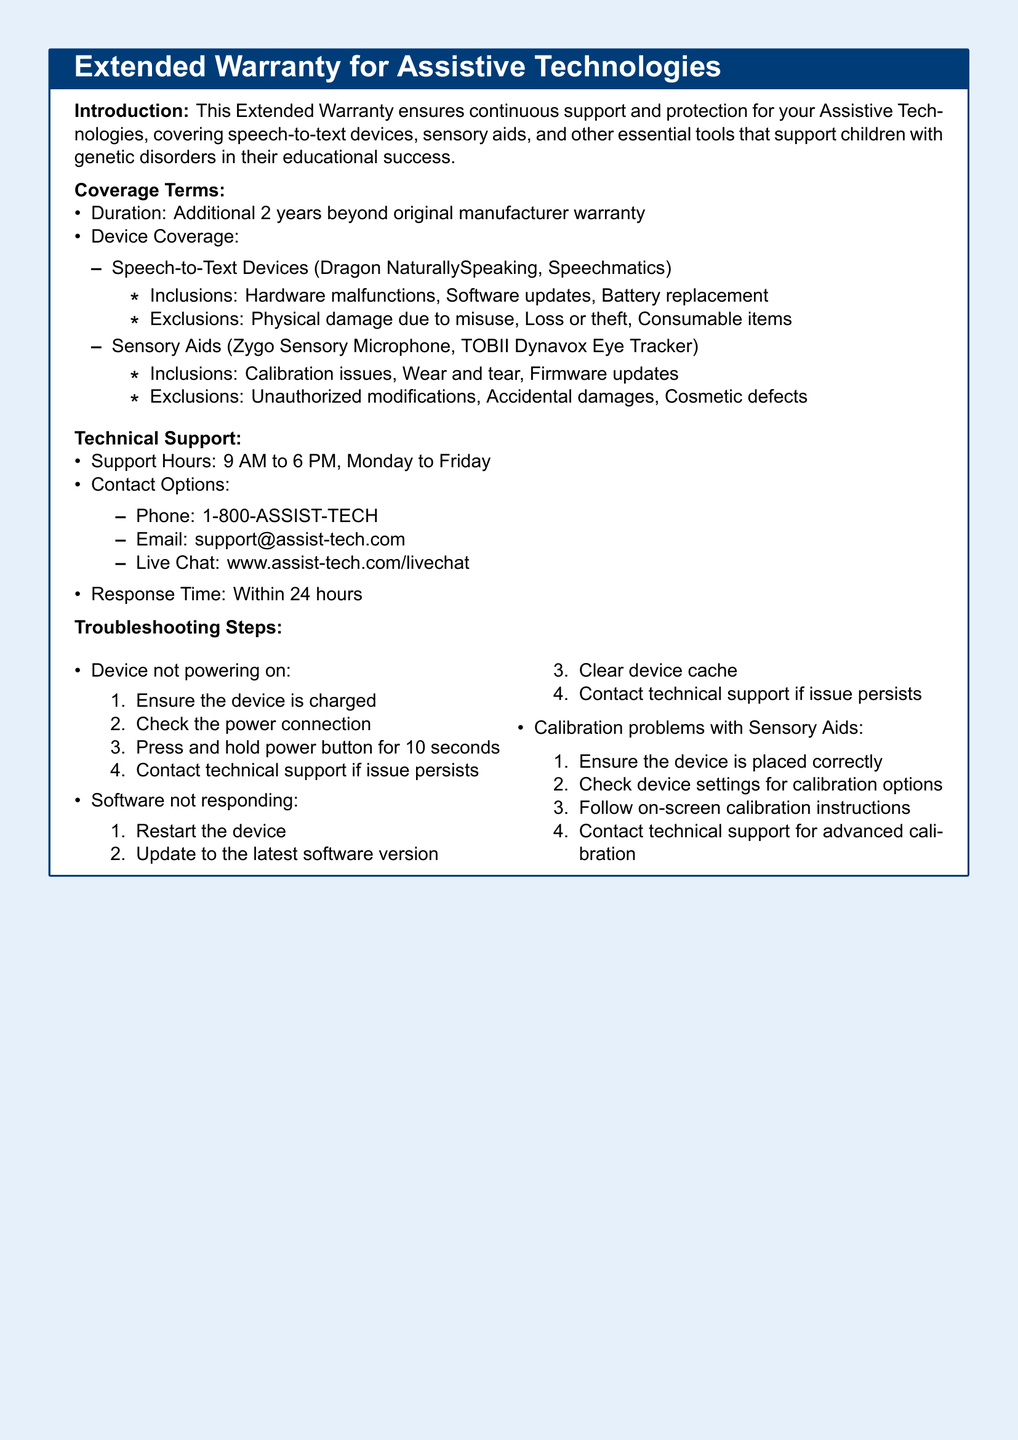What is the duration of the extended warranty? The document states the duration of the warranty is additional 2 years beyond the original manufacturer warranty.
Answer: 2 years What types of devices are covered under the warranty? The document lists Speech-to-Text Devices and Sensory Aids as covered devices.
Answer: Speech-to-Text Devices and Sensory Aids What is the contact phone number for technical support? The phone contact option provided in the document is 1-800-ASSIST-TECH.
Answer: 1-800-ASSIST-TECH During which hours is technical support available? The support hours are mentioned as 9 AM to 6 PM, Monday to Friday.
Answer: 9 AM to 6 PM, Monday to Friday What should you do if the device is not powering on? The troubleshooting steps provide a specific series of actions to take, including ensuring the device is charged.
Answer: Ensure the device is charged What type of damages are excluded from the warranty for Sensory Aids? The document specifies that unauthorized modifications, accidental damages, and cosmetic defects are excluded.
Answer: Unauthorized modifications, accidental damages, cosmetic defects What is the response time for technical support inquiries? The document indicates that the response time is within 24 hours.
Answer: Within 24 hours What must you check if the software is not responding? The troubleshooting list includes restarting the device as the first step.
Answer: Restart the device What action should be taken for advanced calibration of Sensory Aids? According to the troubleshooting steps, you should contact technical support for advanced calibration.
Answer: Contact technical support for advanced calibration 